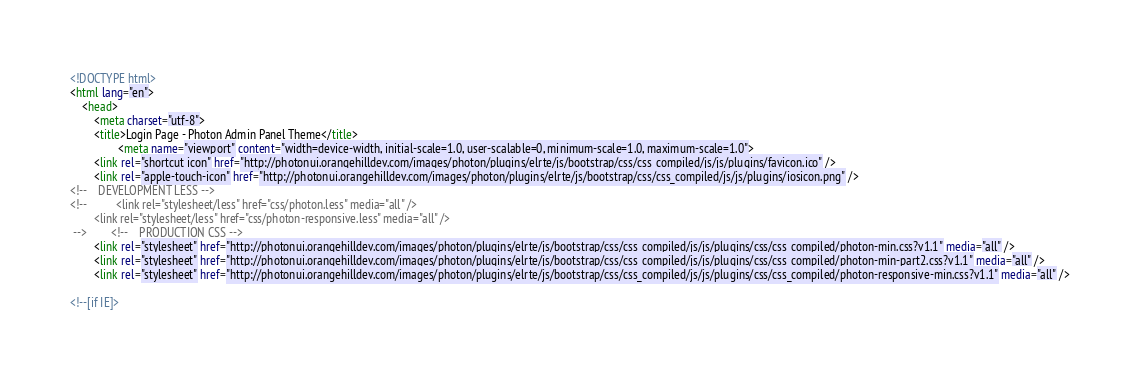<code> <loc_0><loc_0><loc_500><loc_500><_HTML_><!DOCTYPE html>
<html lang="en">
    <head>
        <meta charset="utf-8">
        <title>Login Page - Photon Admin Panel Theme</title>
                <meta name="viewport" content="width=device-width, initial-scale=1.0, user-scalable=0, minimum-scale=1.0, maximum-scale=1.0">
        <link rel="shortcut icon" href="http://photonui.orangehilldev.com/images/photon/plugins/elrte/js/bootstrap/css/css_compiled/js/js/plugins/favicon.ico" />
        <link rel="apple-touch-icon" href="http://photonui.orangehilldev.com/images/photon/plugins/elrte/js/bootstrap/css/css_compiled/js/js/plugins/iosicon.png" />
<!--    DEVELOPMENT LESS -->
<!--          <link rel="stylesheet/less" href="css/photon.less" media="all" />
        <link rel="stylesheet/less" href="css/photon-responsive.less" media="all" />
 -->        <!--    PRODUCTION CSS -->
        <link rel="stylesheet" href="http://photonui.orangehilldev.com/images/photon/plugins/elrte/js/bootstrap/css/css_compiled/js/js/plugins/css/css_compiled/photon-min.css?v1.1" media="all" />
        <link rel="stylesheet" href="http://photonui.orangehilldev.com/images/photon/plugins/elrte/js/bootstrap/css/css_compiled/js/js/plugins/css/css_compiled/photon-min-part2.css?v1.1" media="all" />
        <link rel="stylesheet" href="http://photonui.orangehilldev.com/images/photon/plugins/elrte/js/bootstrap/css/css_compiled/js/js/plugins/css/css_compiled/photon-responsive-min.css?v1.1" media="all" />

<!--[if IE]></code> 